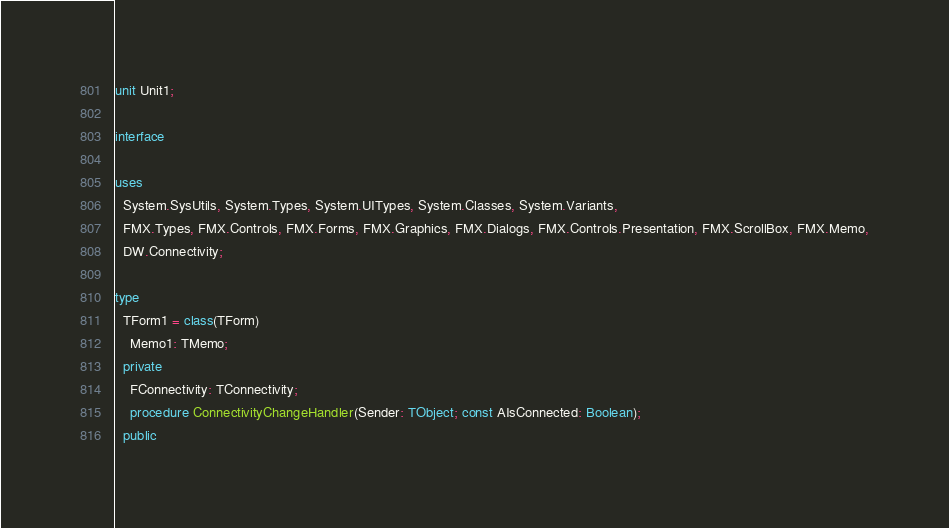<code> <loc_0><loc_0><loc_500><loc_500><_Pascal_>unit Unit1;

interface

uses
  System.SysUtils, System.Types, System.UITypes, System.Classes, System.Variants,
  FMX.Types, FMX.Controls, FMX.Forms, FMX.Graphics, FMX.Dialogs, FMX.Controls.Presentation, FMX.ScrollBox, FMX.Memo,
  DW.Connectivity;

type
  TForm1 = class(TForm)
    Memo1: TMemo;
  private
    FConnectivity: TConnectivity;
    procedure ConnectivityChangeHandler(Sender: TObject; const AIsConnected: Boolean);
  public</code> 